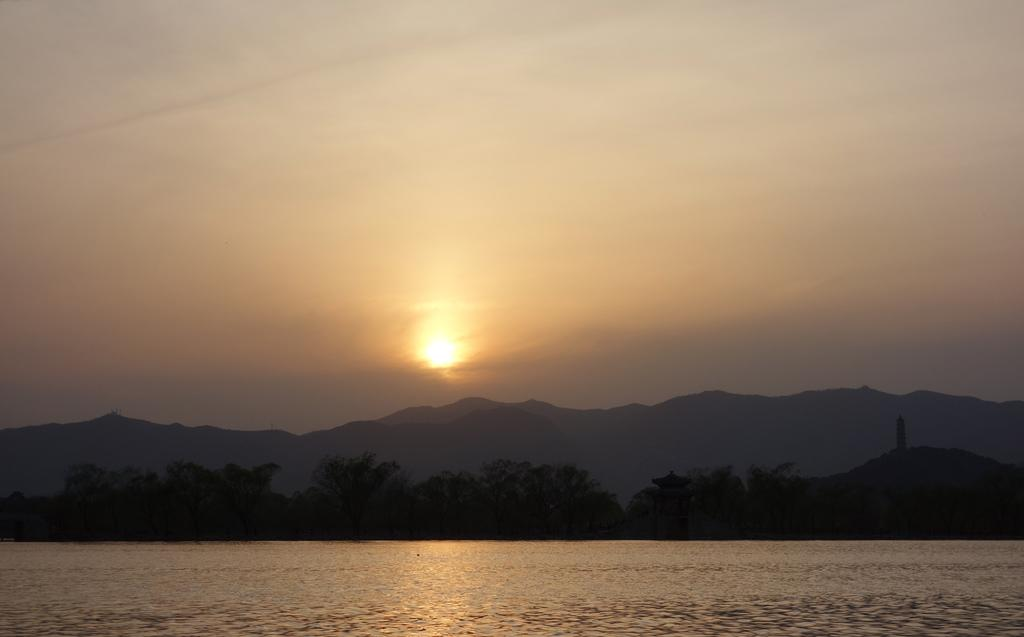What is the primary element visible in the image? There is water in the image. What can be seen in the background of the image? There are trees and mountains in the background of the image. What is visible at the top of the image? The sky is visible at the top of the image. Can the sun be seen in the sky? Yes, the sun is observable in the sky. What word can be heard being spoken by the metal in the image? There is no metal present in the image, and therefore no words can be heard. 